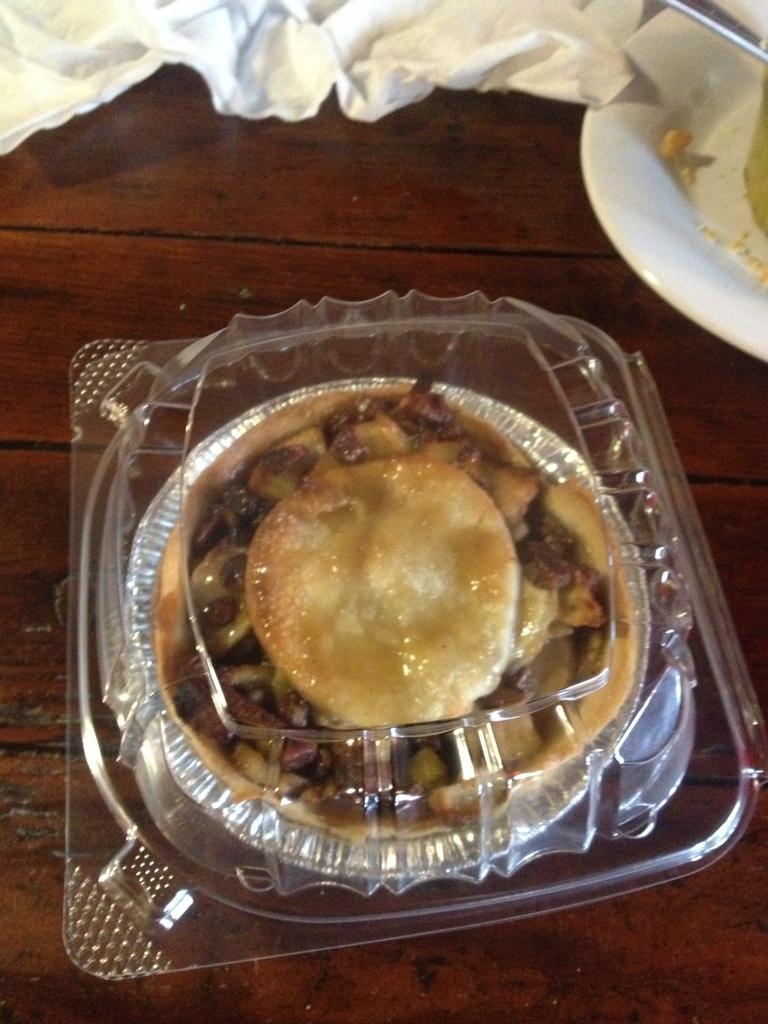How would you summarize this image in a sentence or two? In this image, we can see some food in a container. We can see the wooden surface. We can see some cloth and a white colored container with an object. 